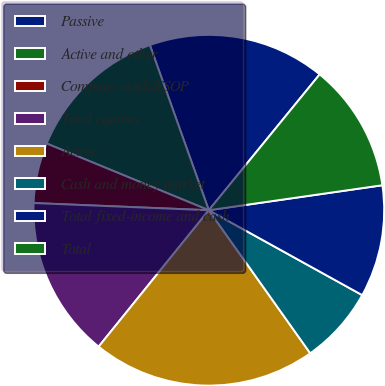Convert chart. <chart><loc_0><loc_0><loc_500><loc_500><pie_chart><fcel>Passive<fcel>Active and other<fcel>Company stock/ESOP<fcel>Total equities<fcel>Active<fcel>Cash and money market<fcel>Total fixed-income and cash<fcel>Total<nl><fcel>16.35%<fcel>13.33%<fcel>5.56%<fcel>14.84%<fcel>20.63%<fcel>7.14%<fcel>10.32%<fcel>11.83%<nl></chart> 